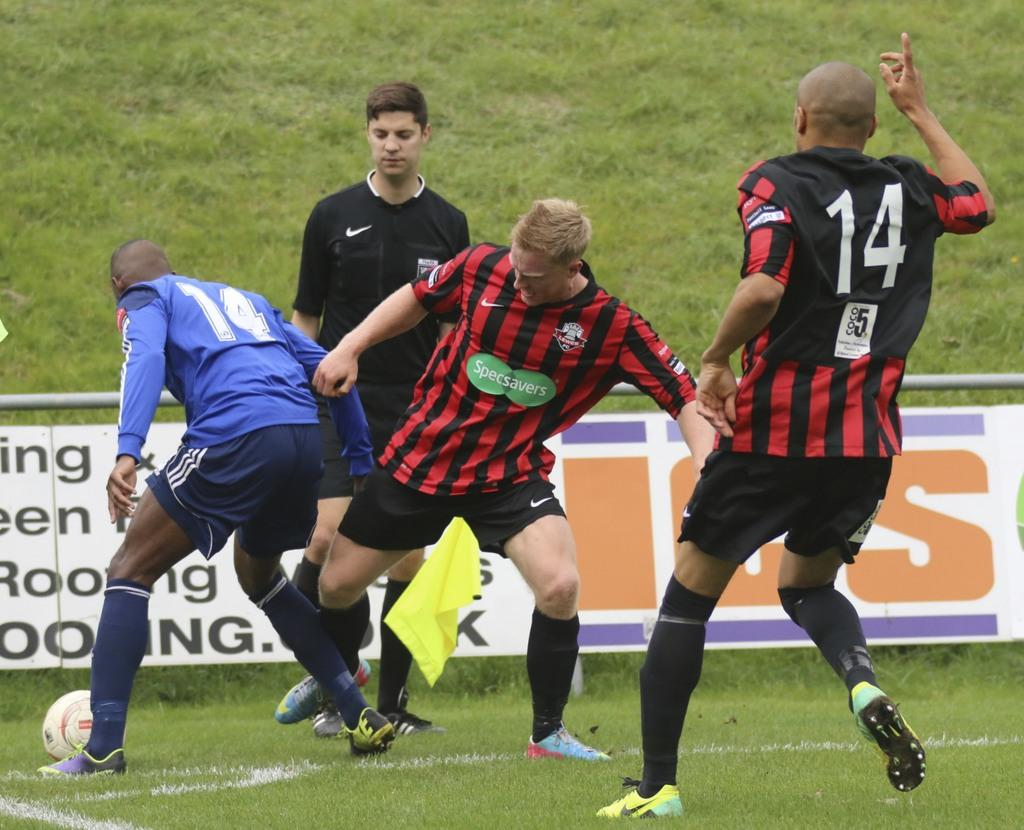<image>
Give a short and clear explanation of the subsequent image. A player with number 14 holds up his right hand. 